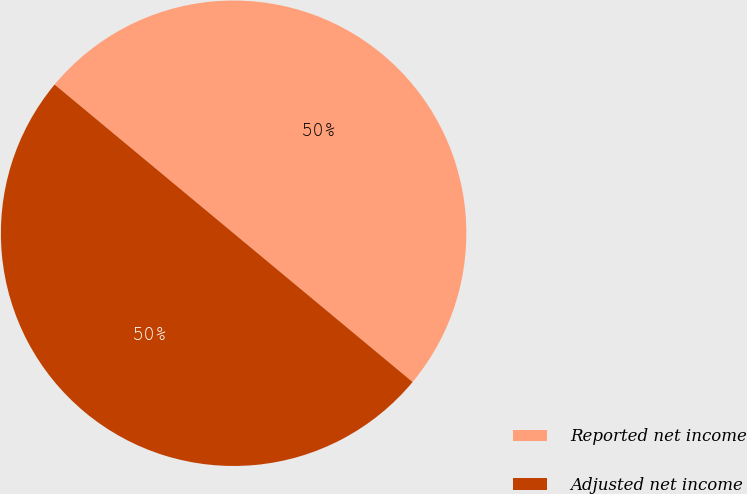<chart> <loc_0><loc_0><loc_500><loc_500><pie_chart><fcel>Reported net income<fcel>Adjusted net income<nl><fcel>50.0%<fcel>50.0%<nl></chart> 